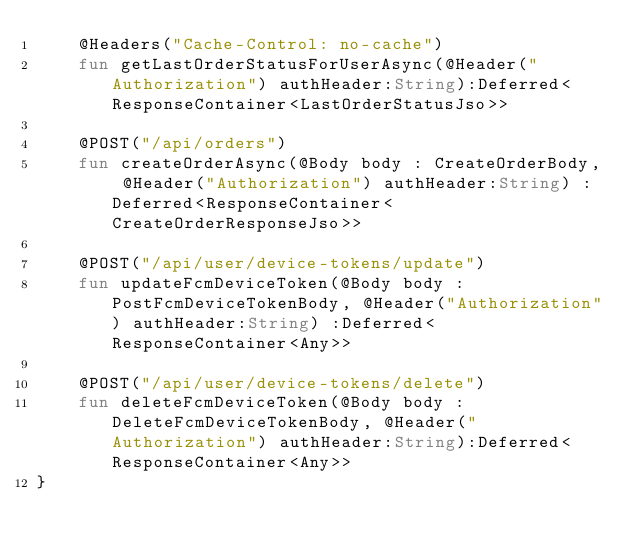Convert code to text. <code><loc_0><loc_0><loc_500><loc_500><_Kotlin_>    @Headers("Cache-Control: no-cache")
    fun getLastOrderStatusForUserAsync(@Header("Authorization") authHeader:String):Deferred<ResponseContainer<LastOrderStatusJso>>

    @POST("/api/orders")
    fun createOrderAsync(@Body body : CreateOrderBody, @Header("Authorization") authHeader:String) :Deferred<ResponseContainer<CreateOrderResponseJso>>

    @POST("/api/user/device-tokens/update")
    fun updateFcmDeviceToken(@Body body : PostFcmDeviceTokenBody, @Header("Authorization") authHeader:String) :Deferred<ResponseContainer<Any>>

    @POST("/api/user/device-tokens/delete")
    fun deleteFcmDeviceToken(@Body body : DeleteFcmDeviceTokenBody, @Header("Authorization") authHeader:String):Deferred<ResponseContainer<Any>>
}</code> 